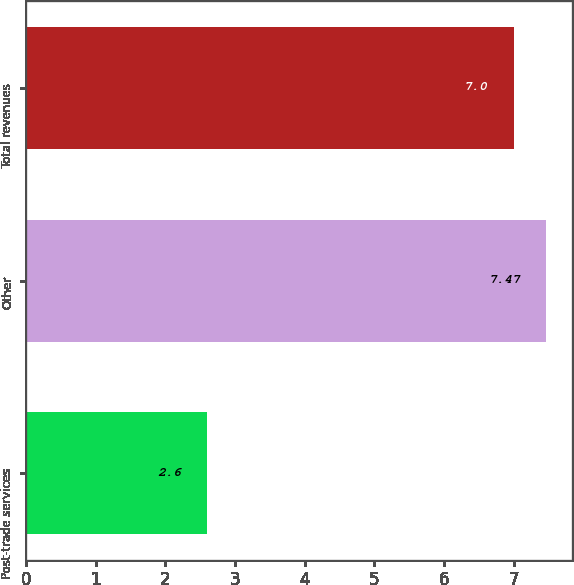Convert chart. <chart><loc_0><loc_0><loc_500><loc_500><bar_chart><fcel>Post-trade services<fcel>Other<fcel>Total revenues<nl><fcel>2.6<fcel>7.47<fcel>7<nl></chart> 